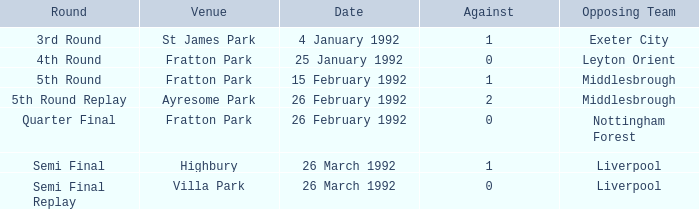What was the round for Villa Park? Semi Final Replay. 